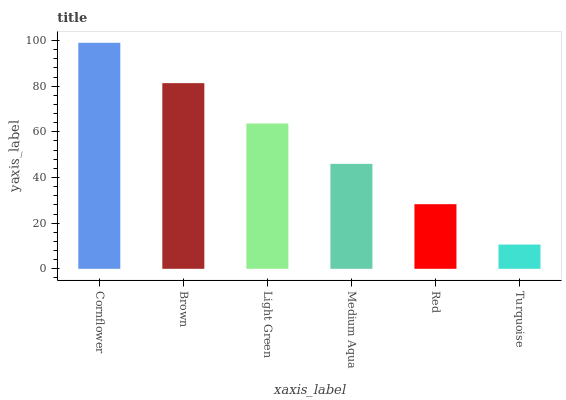Is Turquoise the minimum?
Answer yes or no. Yes. Is Cornflower the maximum?
Answer yes or no. Yes. Is Brown the minimum?
Answer yes or no. No. Is Brown the maximum?
Answer yes or no. No. Is Cornflower greater than Brown?
Answer yes or no. Yes. Is Brown less than Cornflower?
Answer yes or no. Yes. Is Brown greater than Cornflower?
Answer yes or no. No. Is Cornflower less than Brown?
Answer yes or no. No. Is Light Green the high median?
Answer yes or no. Yes. Is Medium Aqua the low median?
Answer yes or no. Yes. Is Brown the high median?
Answer yes or no. No. Is Red the low median?
Answer yes or no. No. 